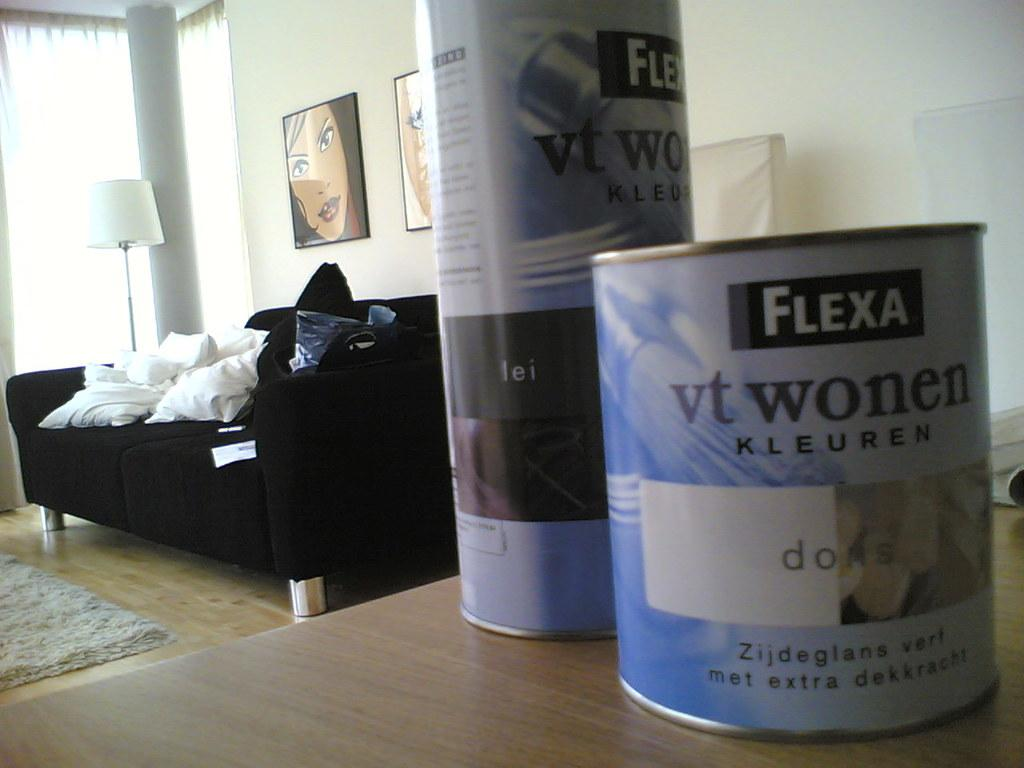<image>
Provide a brief description of the given image. Small can of paint by FLEXA next to a tall can of paint. 